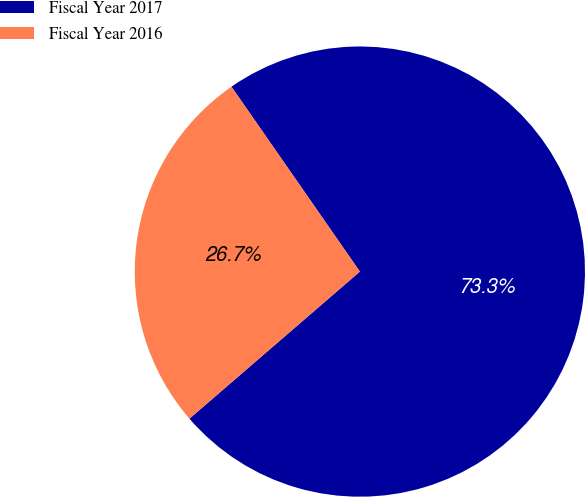Convert chart. <chart><loc_0><loc_0><loc_500><loc_500><pie_chart><fcel>Fiscal Year 2017<fcel>Fiscal Year 2016<nl><fcel>73.33%<fcel>26.67%<nl></chart> 